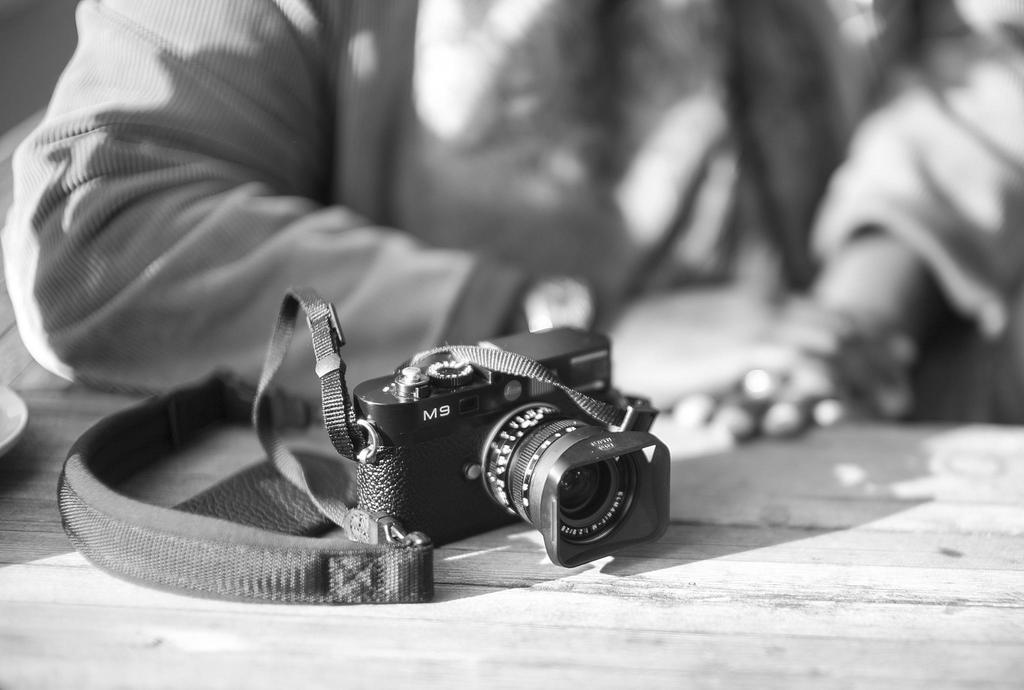<image>
Describe the image concisely. An M9 camera sits on a table in front of someone. 